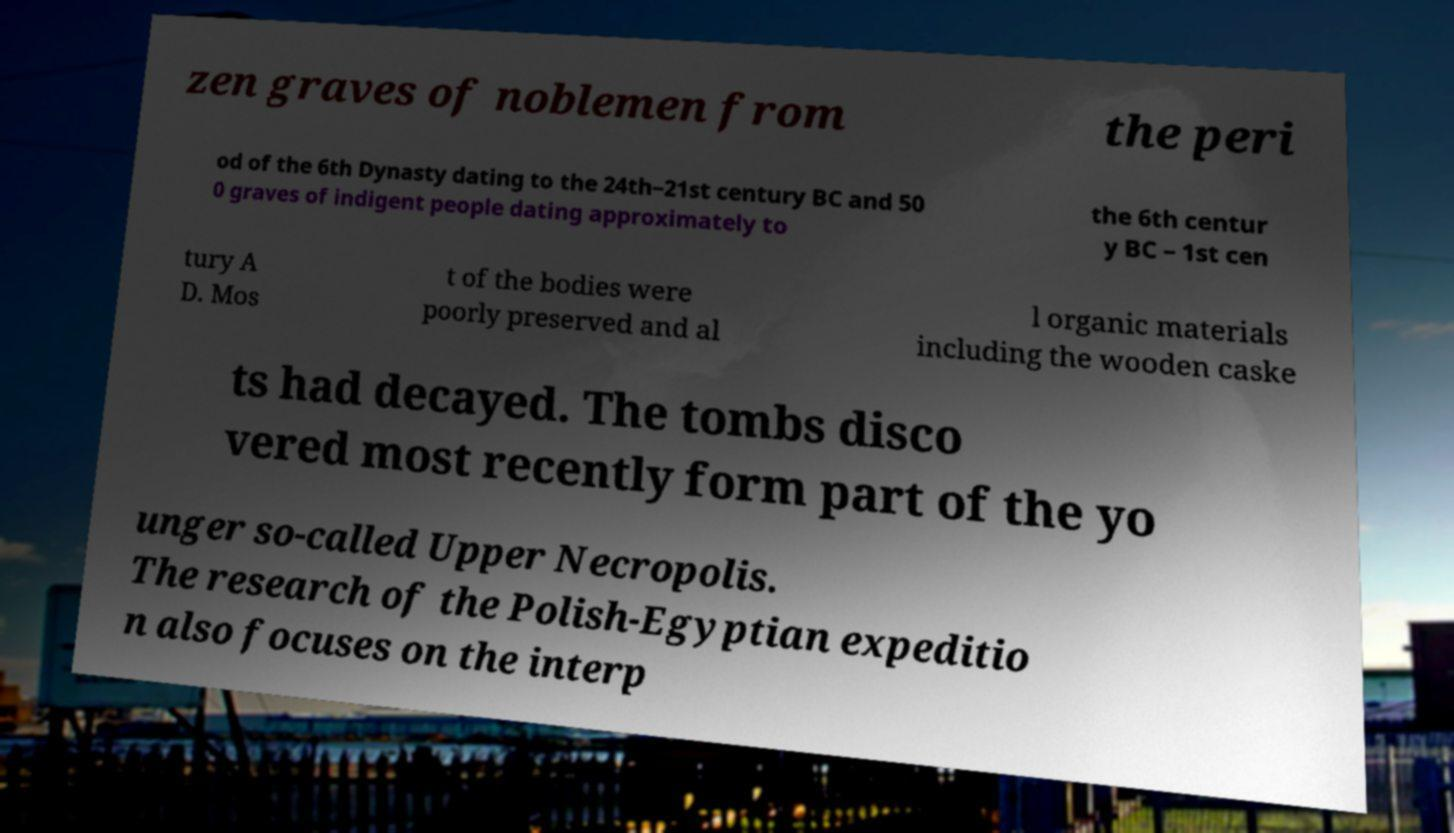I need the written content from this picture converted into text. Can you do that? zen graves of noblemen from the peri od of the 6th Dynasty dating to the 24th–21st century BC and 50 0 graves of indigent people dating approximately to the 6th centur y BC – 1st cen tury A D. Mos t of the bodies were poorly preserved and al l organic materials including the wooden caske ts had decayed. The tombs disco vered most recently form part of the yo unger so-called Upper Necropolis. The research of the Polish-Egyptian expeditio n also focuses on the interp 